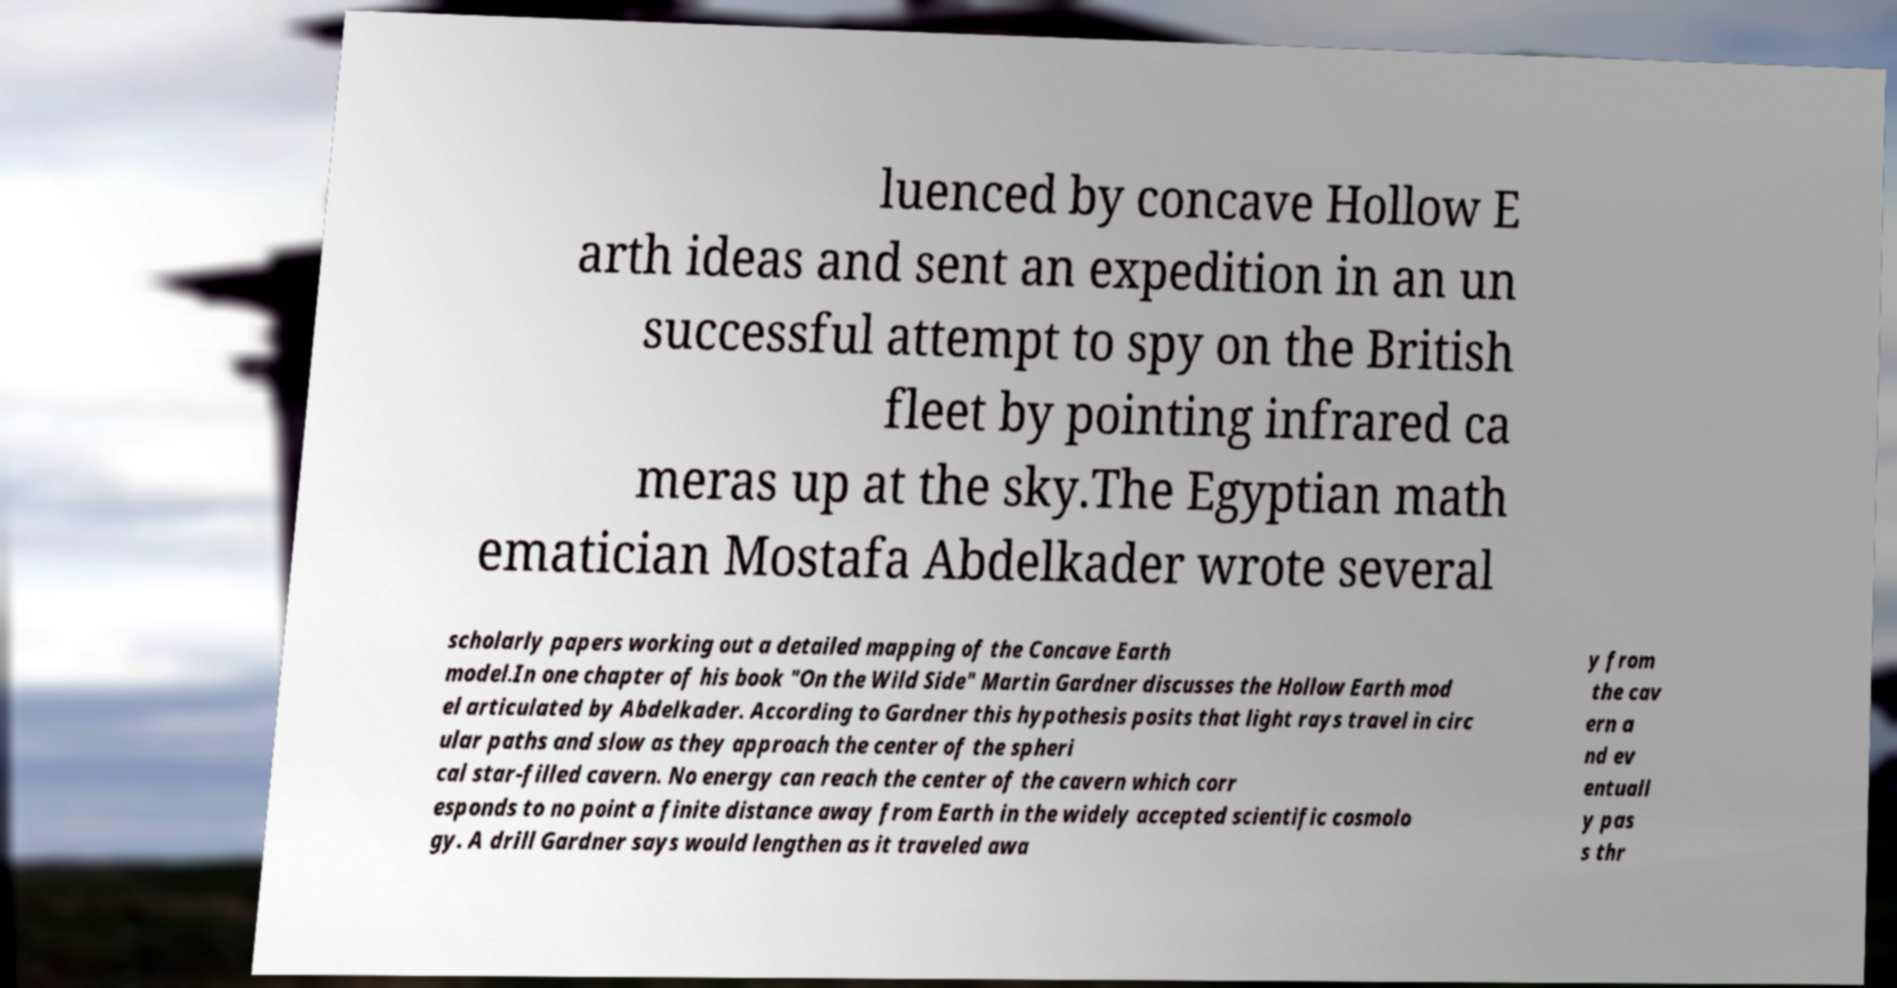Could you assist in decoding the text presented in this image and type it out clearly? luenced by concave Hollow E arth ideas and sent an expedition in an un successful attempt to spy on the British fleet by pointing infrared ca meras up at the sky.The Egyptian math ematician Mostafa Abdelkader wrote several scholarly papers working out a detailed mapping of the Concave Earth model.In one chapter of his book "On the Wild Side" Martin Gardner discusses the Hollow Earth mod el articulated by Abdelkader. According to Gardner this hypothesis posits that light rays travel in circ ular paths and slow as they approach the center of the spheri cal star-filled cavern. No energy can reach the center of the cavern which corr esponds to no point a finite distance away from Earth in the widely accepted scientific cosmolo gy. A drill Gardner says would lengthen as it traveled awa y from the cav ern a nd ev entuall y pas s thr 